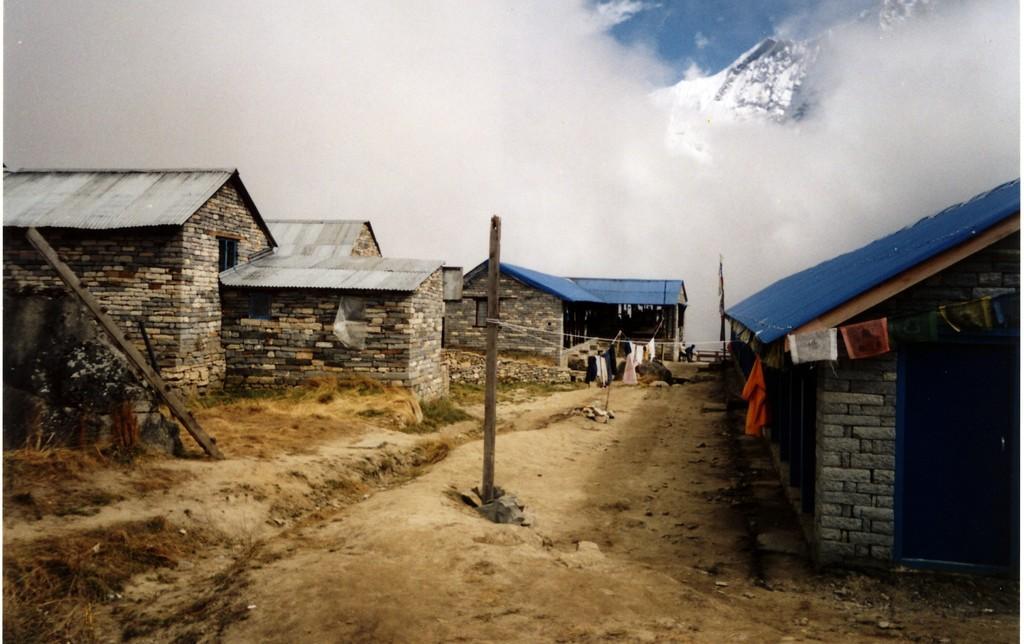How would you summarize this image in a sentence or two? In this picture we can see a few poles, ropes, clothes, houses and some dry grass on the ground. We can see the sky. 